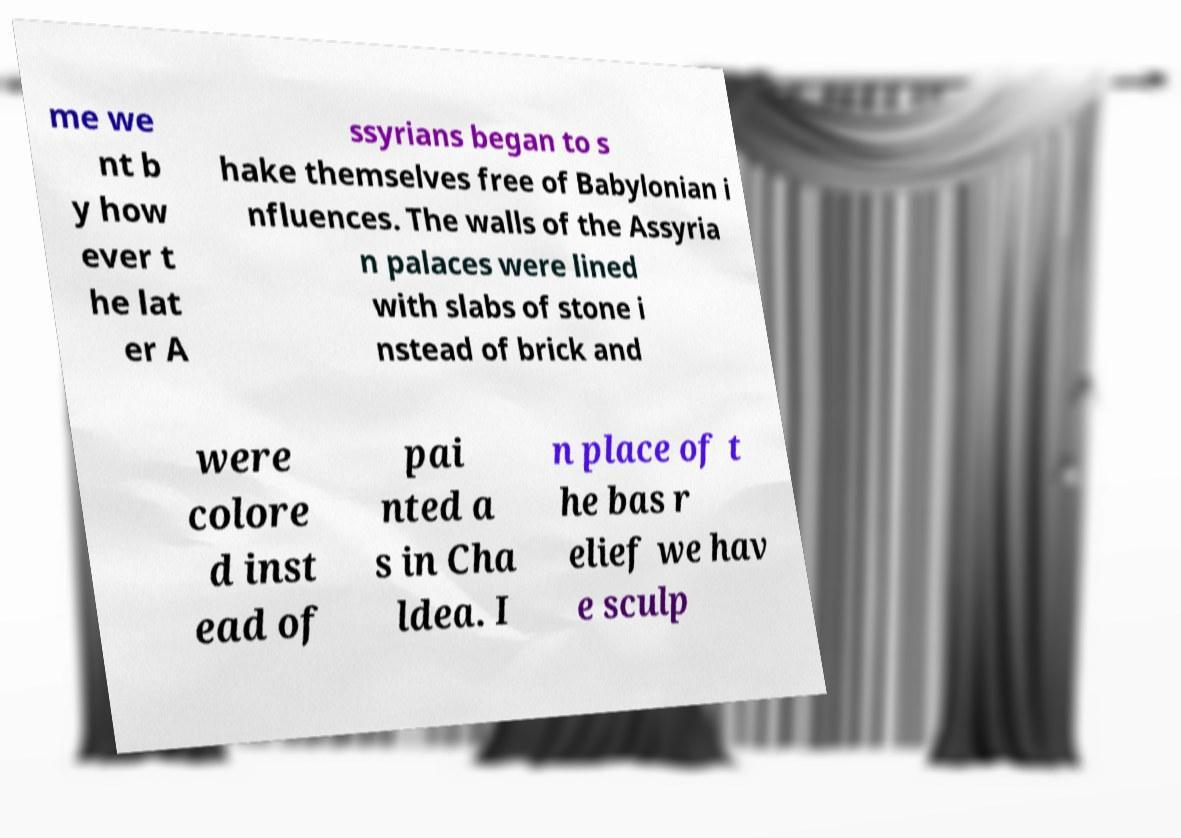Could you assist in decoding the text presented in this image and type it out clearly? me we nt b y how ever t he lat er A ssyrians began to s hake themselves free of Babylonian i nfluences. The walls of the Assyria n palaces were lined with slabs of stone i nstead of brick and were colore d inst ead of pai nted a s in Cha ldea. I n place of t he bas r elief we hav e sculp 